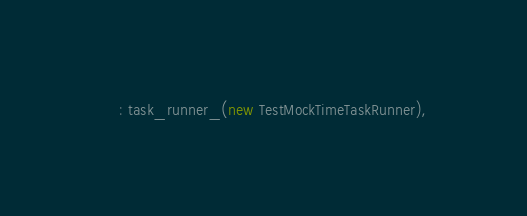Convert code to text. <code><loc_0><loc_0><loc_500><loc_500><_C++_>    : task_runner_(new TestMockTimeTaskRunner),</code> 